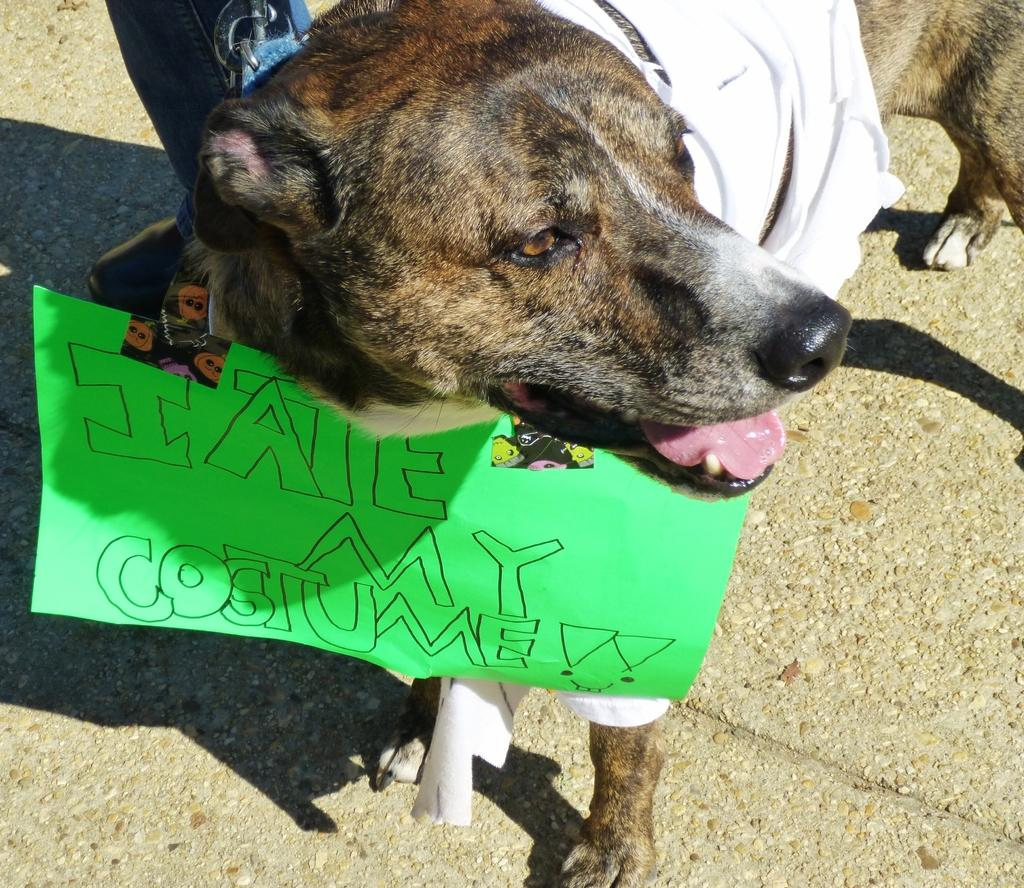What type of animal is in the image? There is a dog in the image. What is the dog wearing? The dog is wearing a white dress. Is there anything attached to the dog? Yes, there is a paper attached to the dog. Can you describe the person in the background of the image? The person is holding the dog with a chain. What verse is the dog reciting in the image? There is no indication in the image that the dog is reciting a verse, as dogs do not have the ability to speak or recite verses. 